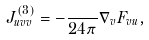Convert formula to latex. <formula><loc_0><loc_0><loc_500><loc_500>J ^ { ( 3 ) } _ { u v v } = - \frac { } { 2 4 \pi } \nabla _ { v } F _ { v u } ,</formula> 